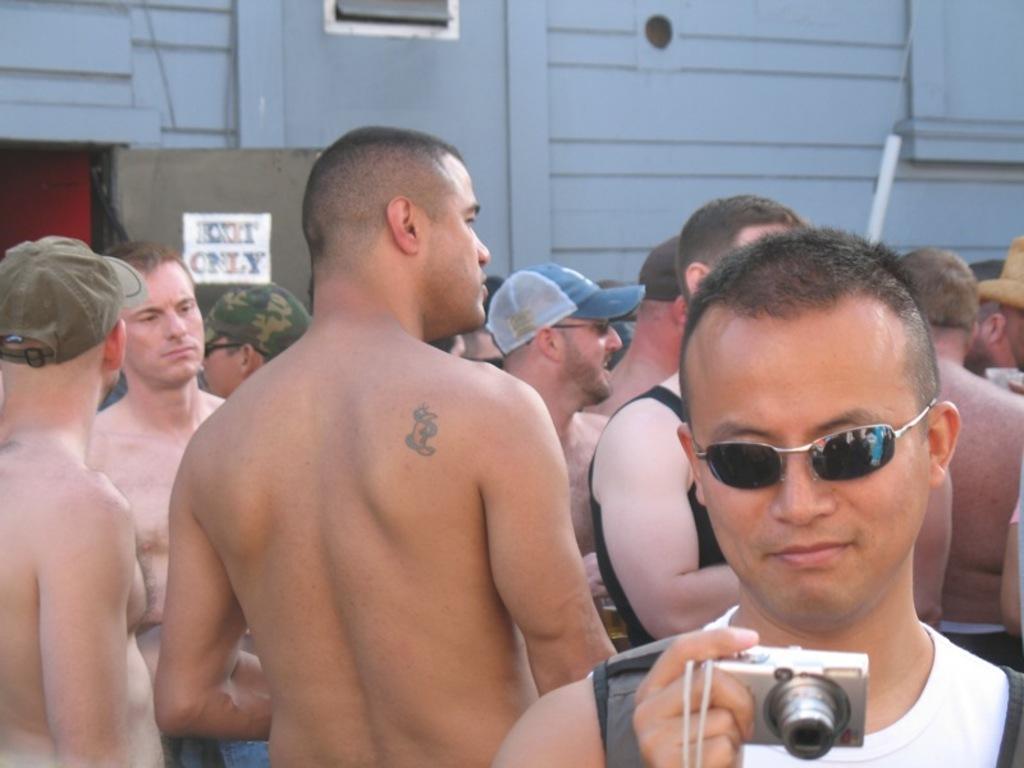How would you summarize this image in a sentence or two? In this image there are group of persons standing. This man at the right side is holding a camera, the man standing in the middle is wearing a blue colour hat,at the left side the man is wearing a military colour hat, at the bottom left the man is wearing a brown colour hat. In the background there is a building with a ventilator and a door with a name exit only. 